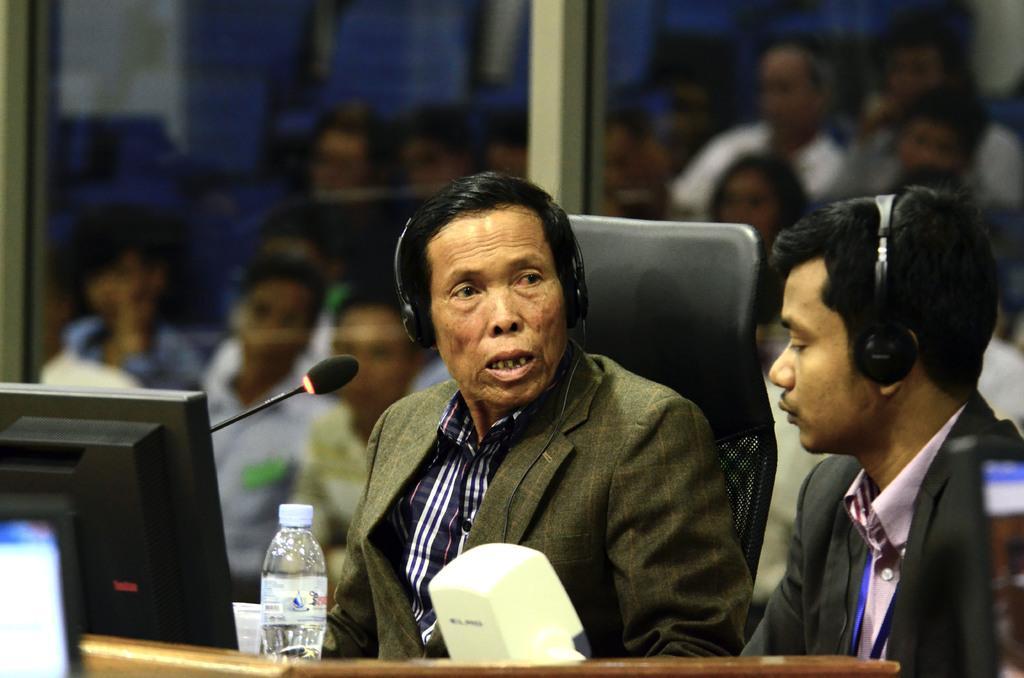Can you describe this image briefly? In this picture there is a person who is sitting at the center of the image and there is a mic and laptop in front of him, there is another person at the right side of the image, they both are having headsets, it seems to be a conference meeting. 